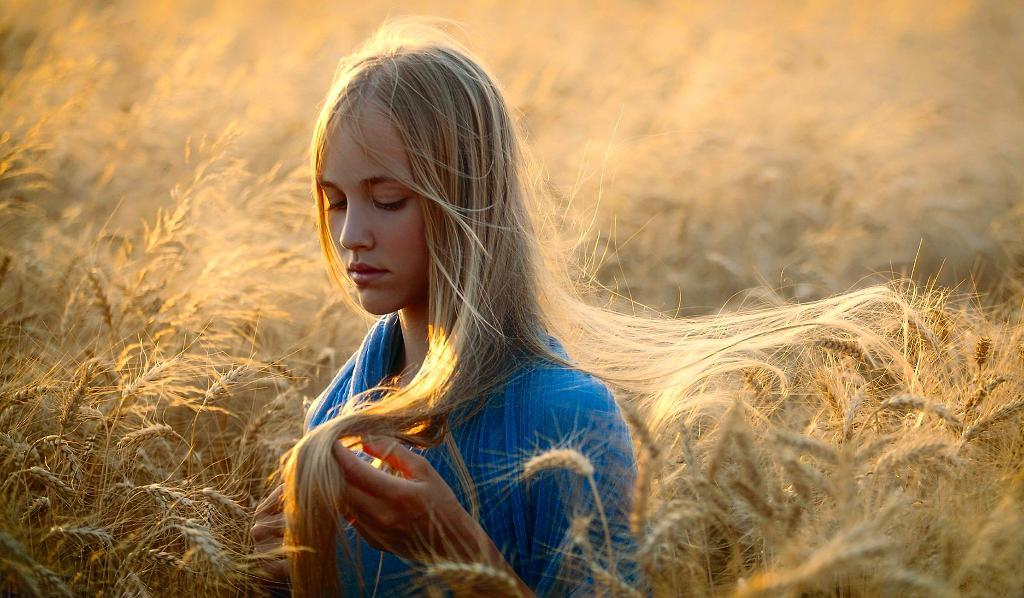Who is the main subject in the image? There is a woman in the image. Can you describe the woman's position in the image? The woman is standing in the front. What is the woman wearing in the image? The woman is wearing a blue dress. What can be seen on both sides of the woman in the image? There are yellow color plants on both sides of the woman. What type of rhythm can be heard coming from the woman in the image? There is no indication in the image that the woman is producing any rhythm, so it's not possible to determine what, if any, rhythm might be heard. 